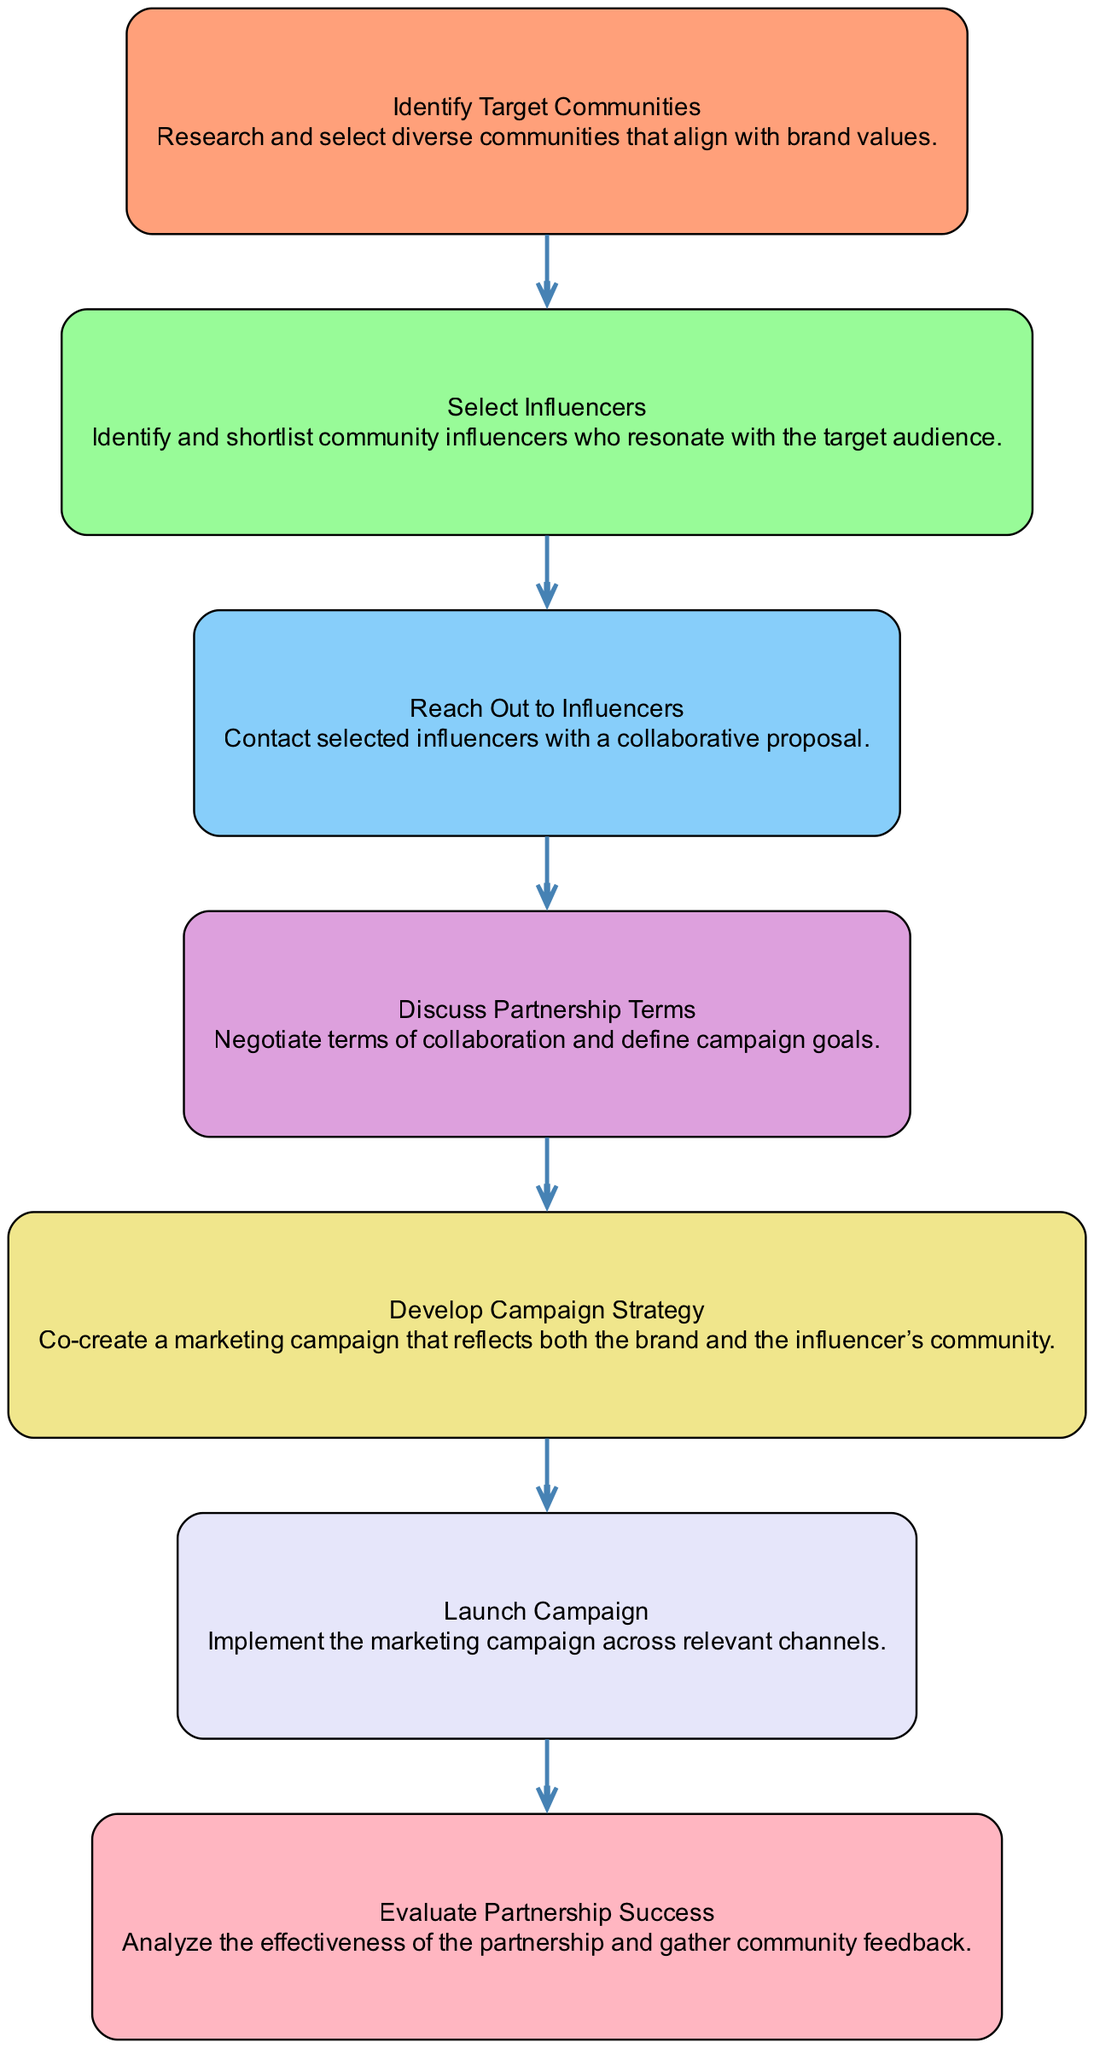What is the first step in the sequence? The first step in the sequence is identified by the node labeled "Identify Target Communities", which indicates the starting action in the process of partnering with community influencers.
Answer: Identify Target Communities How many total steps are involved in the process? By counting the nodes from step 1 to step 7 in the diagram, we find there are a total of 7 distinct actions required to partner with community influencers.
Answer: 7 Which step directly follows "Reach Out to Influencers"? According to the flow of the diagram, the step that follows "Reach Out to Influencers" is "Discuss Partnership Terms", as it is the next node in the sequence after the outreach.
Answer: Discuss Partnership Terms What action is taken in the "Develop Campaign Strategy" step? The action associated with the "Develop Campaign Strategy" step is defined as co-creating a marketing campaign that reflects both the brand and the influencer's community, which involves collaborative planning.
Answer: Co-create a marketing campaign In which step is the effectiveness of the partnership analyzed? The effectiveness of the partnership is analyzed in the final step of the sequence, labeled "Evaluate Partnership Success", which focuses on gathering feedback and assessing the impact of the collaboration.
Answer: Evaluate Partnership Success What is the relationship between "Select Influencers" and "Launch Campaign"? The relationship between "Select Influencers" and "Launch Campaign" is sequential; "Select Influencers" must be completed first before moving on to "Launch Campaign", indicating a progression where one step leads into the next in the diagram.
Answer: Sequential progression How many edges are present in the diagram? The edges in the diagram represent the connections between steps; since there are 7 steps, there must be 6 edges connecting them, as each step (except the last) connects to the next.
Answer: 6 What is the last step in the sequence? The last step in the sequence is "Evaluate Partnership Success", marking the conclusion of the process and the point at which the outcomes are reviewed.
Answer: Evaluate Partnership Success 